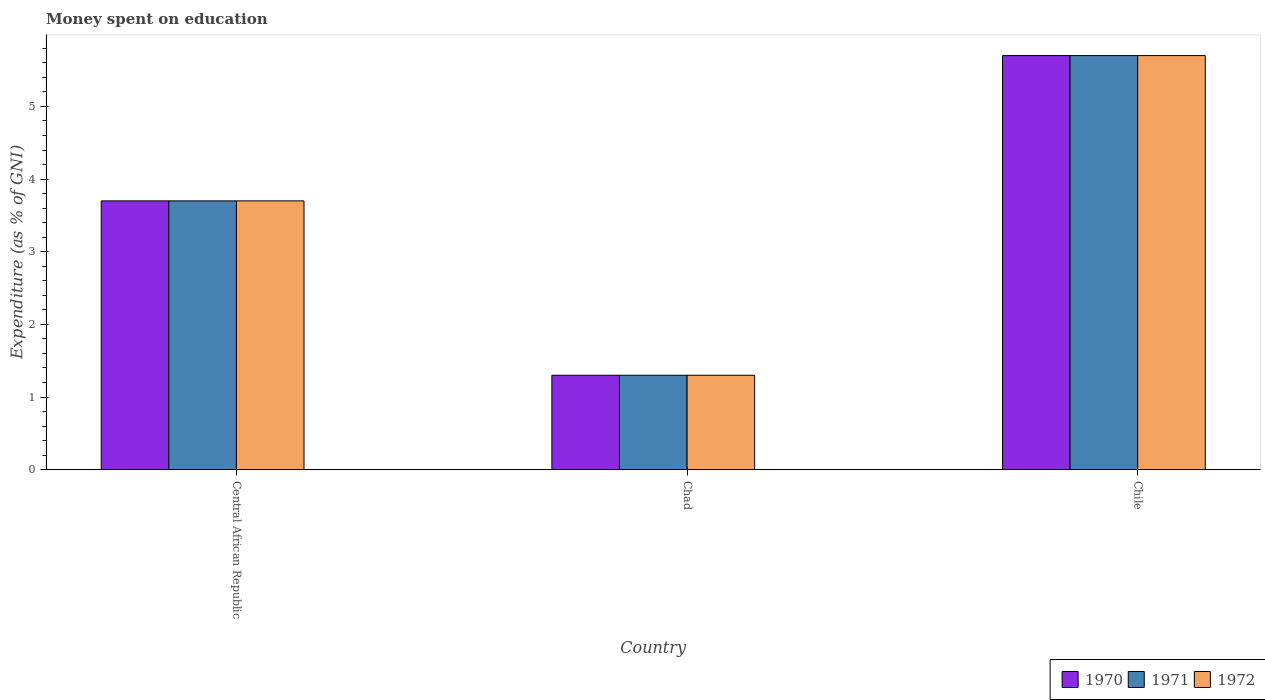Are the number of bars on each tick of the X-axis equal?
Keep it short and to the point. Yes. How many bars are there on the 2nd tick from the left?
Your answer should be very brief. 3. What is the label of the 1st group of bars from the left?
Your answer should be compact. Central African Republic. Across all countries, what is the minimum amount of money spent on education in 1971?
Your answer should be very brief. 1.3. In which country was the amount of money spent on education in 1972 minimum?
Make the answer very short. Chad. What is the average amount of money spent on education in 1970 per country?
Your answer should be compact. 3.57. What is the ratio of the amount of money spent on education in 1970 in Central African Republic to that in Chad?
Keep it short and to the point. 2.85. What is the difference between the highest and the second highest amount of money spent on education in 1971?
Ensure brevity in your answer.  -2.4. What does the 3rd bar from the left in Chile represents?
Your response must be concise. 1972. What is the difference between two consecutive major ticks on the Y-axis?
Offer a terse response. 1. Are the values on the major ticks of Y-axis written in scientific E-notation?
Make the answer very short. No. Where does the legend appear in the graph?
Give a very brief answer. Bottom right. How are the legend labels stacked?
Your answer should be compact. Horizontal. What is the title of the graph?
Your answer should be compact. Money spent on education. Does "1969" appear as one of the legend labels in the graph?
Give a very brief answer. No. What is the label or title of the Y-axis?
Ensure brevity in your answer.  Expenditure (as % of GNI). What is the Expenditure (as % of GNI) of 1970 in Central African Republic?
Give a very brief answer. 3.7. What is the Expenditure (as % of GNI) in 1970 in Chad?
Offer a very short reply. 1.3. What is the Expenditure (as % of GNI) in 1971 in Chad?
Your answer should be very brief. 1.3. What is the Expenditure (as % of GNI) of 1971 in Chile?
Offer a very short reply. 5.7. Across all countries, what is the maximum Expenditure (as % of GNI) in 1971?
Offer a terse response. 5.7. Across all countries, what is the minimum Expenditure (as % of GNI) of 1972?
Provide a succinct answer. 1.3. What is the total Expenditure (as % of GNI) of 1971 in the graph?
Offer a very short reply. 10.7. What is the total Expenditure (as % of GNI) in 1972 in the graph?
Your answer should be very brief. 10.7. What is the difference between the Expenditure (as % of GNI) of 1971 in Central African Republic and that in Chad?
Your answer should be very brief. 2.4. What is the difference between the Expenditure (as % of GNI) in 1970 in Central African Republic and that in Chile?
Offer a terse response. -2. What is the difference between the Expenditure (as % of GNI) in 1970 in Chad and that in Chile?
Give a very brief answer. -4.4. What is the difference between the Expenditure (as % of GNI) in 1971 in Chad and that in Chile?
Provide a short and direct response. -4.4. What is the difference between the Expenditure (as % of GNI) of 1972 in Chad and that in Chile?
Make the answer very short. -4.4. What is the difference between the Expenditure (as % of GNI) of 1970 in Central African Republic and the Expenditure (as % of GNI) of 1972 in Chad?
Make the answer very short. 2.4. What is the difference between the Expenditure (as % of GNI) in 1971 in Central African Republic and the Expenditure (as % of GNI) in 1972 in Chad?
Ensure brevity in your answer.  2.4. What is the difference between the Expenditure (as % of GNI) of 1970 in Central African Republic and the Expenditure (as % of GNI) of 1971 in Chile?
Offer a terse response. -2. What is the average Expenditure (as % of GNI) of 1970 per country?
Give a very brief answer. 3.57. What is the average Expenditure (as % of GNI) in 1971 per country?
Offer a very short reply. 3.57. What is the average Expenditure (as % of GNI) in 1972 per country?
Keep it short and to the point. 3.57. What is the difference between the Expenditure (as % of GNI) in 1970 and Expenditure (as % of GNI) in 1971 in Central African Republic?
Your response must be concise. 0. What is the difference between the Expenditure (as % of GNI) in 1971 and Expenditure (as % of GNI) in 1972 in Central African Republic?
Provide a succinct answer. 0. What is the difference between the Expenditure (as % of GNI) of 1970 and Expenditure (as % of GNI) of 1971 in Chad?
Your answer should be very brief. 0. What is the difference between the Expenditure (as % of GNI) in 1970 and Expenditure (as % of GNI) in 1972 in Chad?
Offer a terse response. 0. What is the difference between the Expenditure (as % of GNI) in 1970 and Expenditure (as % of GNI) in 1971 in Chile?
Ensure brevity in your answer.  0. What is the difference between the Expenditure (as % of GNI) in 1970 and Expenditure (as % of GNI) in 1972 in Chile?
Make the answer very short. 0. What is the ratio of the Expenditure (as % of GNI) in 1970 in Central African Republic to that in Chad?
Offer a very short reply. 2.85. What is the ratio of the Expenditure (as % of GNI) in 1971 in Central African Republic to that in Chad?
Make the answer very short. 2.85. What is the ratio of the Expenditure (as % of GNI) in 1972 in Central African Republic to that in Chad?
Your answer should be compact. 2.85. What is the ratio of the Expenditure (as % of GNI) in 1970 in Central African Republic to that in Chile?
Your answer should be compact. 0.65. What is the ratio of the Expenditure (as % of GNI) in 1971 in Central African Republic to that in Chile?
Your response must be concise. 0.65. What is the ratio of the Expenditure (as % of GNI) of 1972 in Central African Republic to that in Chile?
Offer a terse response. 0.65. What is the ratio of the Expenditure (as % of GNI) in 1970 in Chad to that in Chile?
Provide a short and direct response. 0.23. What is the ratio of the Expenditure (as % of GNI) in 1971 in Chad to that in Chile?
Your answer should be compact. 0.23. What is the ratio of the Expenditure (as % of GNI) of 1972 in Chad to that in Chile?
Provide a short and direct response. 0.23. What is the difference between the highest and the second highest Expenditure (as % of GNI) in 1971?
Your answer should be compact. 2. What is the difference between the highest and the second highest Expenditure (as % of GNI) in 1972?
Offer a very short reply. 2. What is the difference between the highest and the lowest Expenditure (as % of GNI) of 1971?
Offer a very short reply. 4.4. 